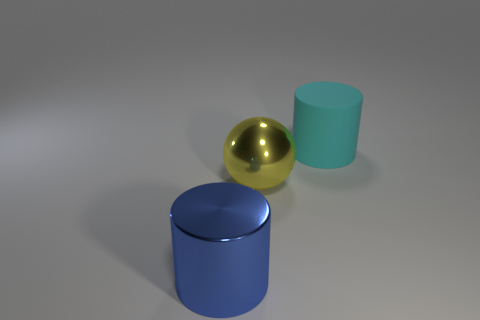Add 2 rubber objects. How many objects exist? 5 Subtract all cylinders. How many objects are left? 1 Subtract all spheres. Subtract all matte cylinders. How many objects are left? 1 Add 3 rubber cylinders. How many rubber cylinders are left? 4 Add 1 big gray blocks. How many big gray blocks exist? 1 Subtract 1 cyan cylinders. How many objects are left? 2 